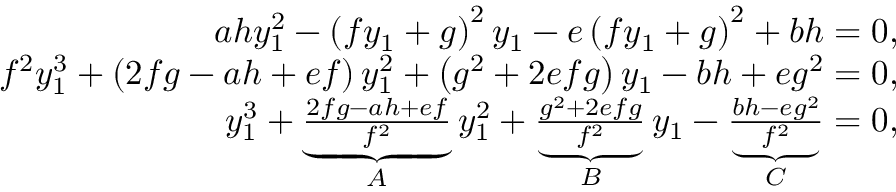Convert formula to latex. <formula><loc_0><loc_0><loc_500><loc_500>\begin{array} { r } { a h y _ { 1 } ^ { 2 } - \left ( f y _ { 1 } + g \right ) ^ { 2 } y _ { 1 } - e \left ( f y _ { 1 } + g \right ) ^ { 2 } + b h = 0 , } \\ { f ^ { 2 } y _ { 1 } ^ { 3 } + \left ( 2 f g - a h + e f \right ) y _ { 1 } ^ { 2 } + \left ( g ^ { 2 } + 2 e f g \right ) y _ { 1 } - b h + e g ^ { 2 } = 0 , } \\ { y _ { 1 } ^ { 3 } + \underbrace { \frac { 2 f g - a h + e f } { f ^ { 2 } } } _ { A } y _ { 1 } ^ { 2 } + \underbrace { \frac { g ^ { 2 } + 2 e f g } { f ^ { 2 } } } _ { B } y _ { 1 } - \underbrace { \frac { b h - e g ^ { 2 } } { f ^ { 2 } } } _ { C } = 0 , } \end{array}</formula> 